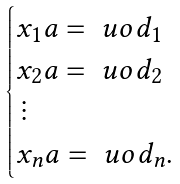Convert formula to latex. <formula><loc_0><loc_0><loc_500><loc_500>\begin{cases} x _ { 1 } a = \ u o d _ { 1 } \\ x _ { 2 } a = \ u o d _ { 2 } \\ \, \vdots \\ x _ { n } a = \ u o d _ { n } . \end{cases}</formula> 